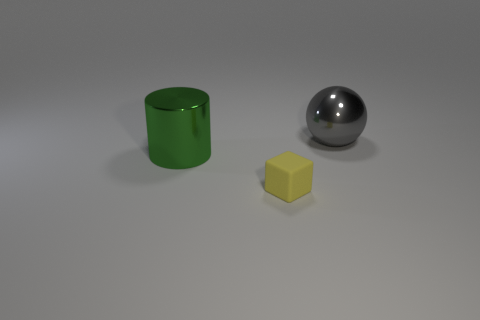Add 1 small purple objects. How many objects exist? 4 Subtract all cylinders. How many objects are left? 2 Add 3 big metal balls. How many big metal balls are left? 4 Add 1 large spheres. How many large spheres exist? 2 Subtract 0 purple balls. How many objects are left? 3 Subtract all small yellow blocks. Subtract all shiny cylinders. How many objects are left? 1 